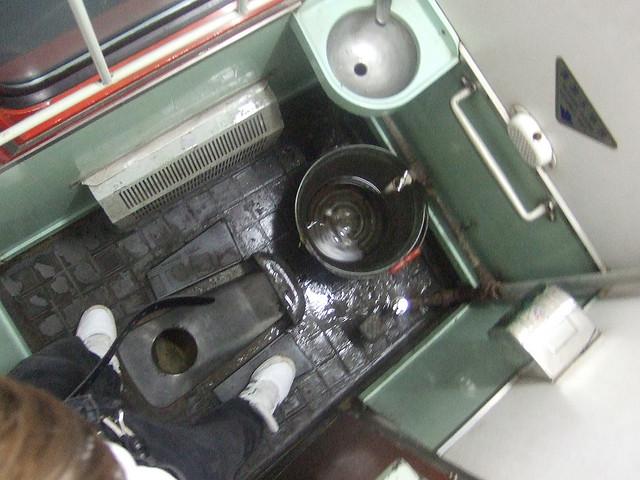What room is this?
Give a very brief answer. Bathroom. What is in the bottom of the sink in the corner?
Concise answer only. Drain. Is this bathroom photograph taken in the United States?
Be succinct. No. What is the toilet paper holder made of?
Give a very brief answer. Metal. 